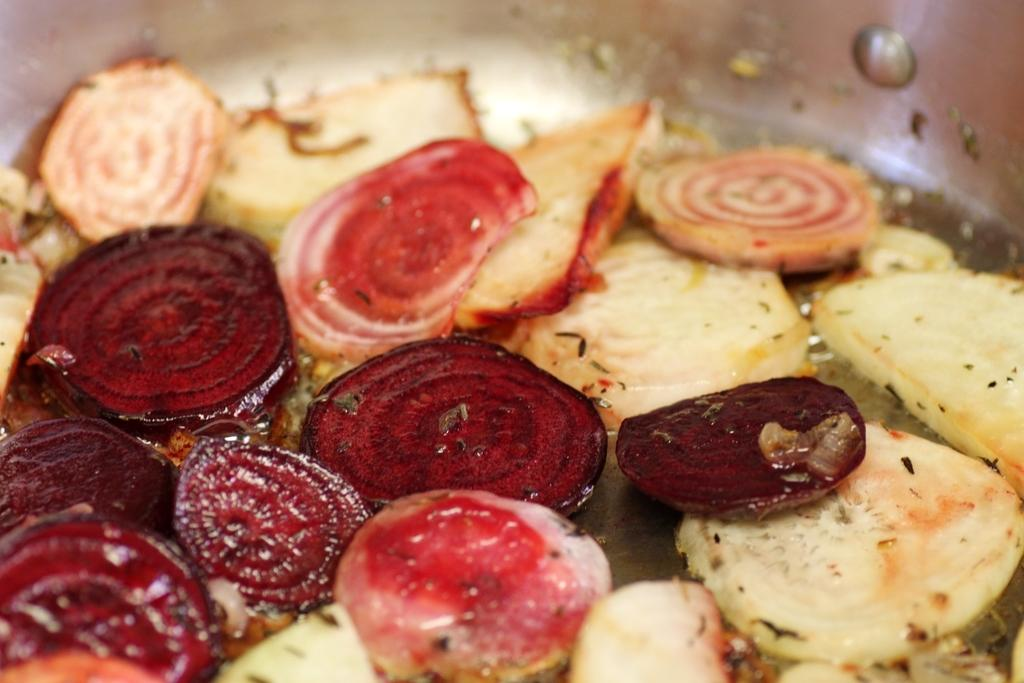What type of food can be seen in the image? There is food in the image. Can you describe the colors of the food? The food has cream, red, and maroon colors. What type of cheese is visible in the image? There is no cheese present in the image. Can you describe the texture of the eggnog in the image? There is no eggnog present in the image. 